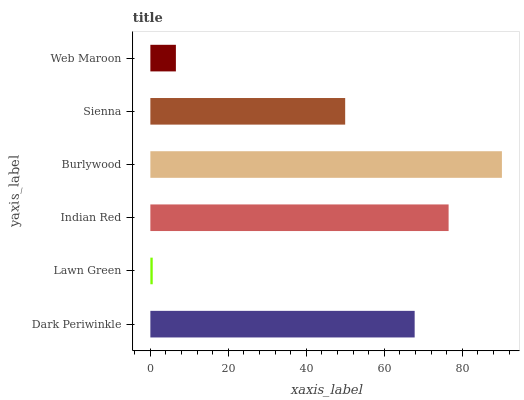Is Lawn Green the minimum?
Answer yes or no. Yes. Is Burlywood the maximum?
Answer yes or no. Yes. Is Indian Red the minimum?
Answer yes or no. No. Is Indian Red the maximum?
Answer yes or no. No. Is Indian Red greater than Lawn Green?
Answer yes or no. Yes. Is Lawn Green less than Indian Red?
Answer yes or no. Yes. Is Lawn Green greater than Indian Red?
Answer yes or no. No. Is Indian Red less than Lawn Green?
Answer yes or no. No. Is Dark Periwinkle the high median?
Answer yes or no. Yes. Is Sienna the low median?
Answer yes or no. Yes. Is Web Maroon the high median?
Answer yes or no. No. Is Dark Periwinkle the low median?
Answer yes or no. No. 